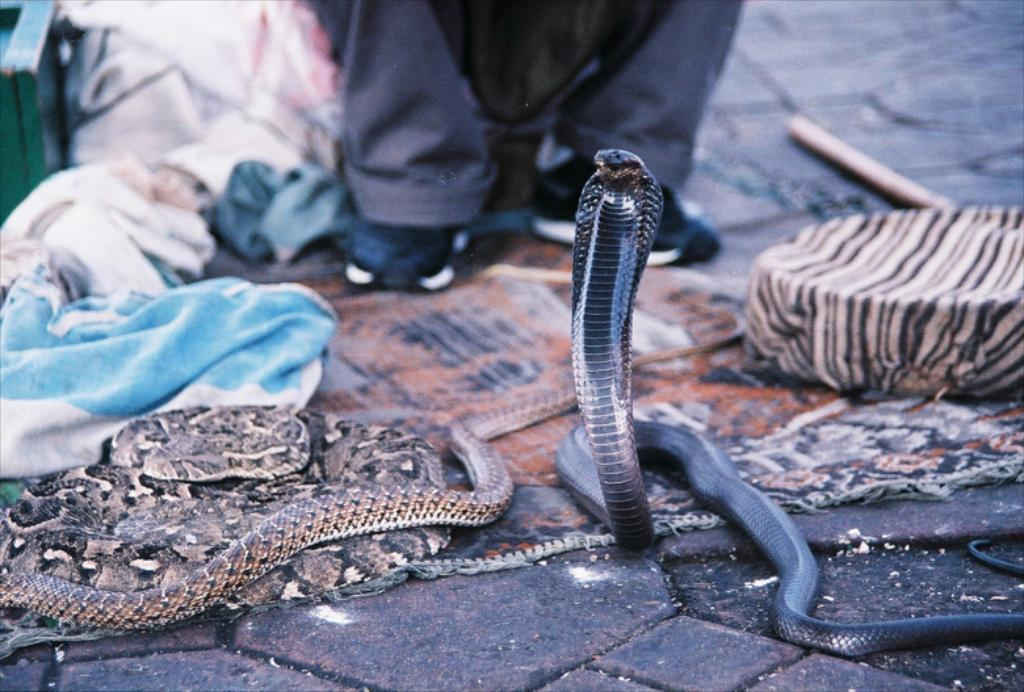What type of animals are present in the image? There are snakes in the image. What is the container for the snakes called? There is a snake box in the image. Where is the snake box located? The snake box is on a mat. What is the surface beneath the mat? The mat is on the land. What other items can be seen in the image? There are clothes and a stick in the image. Are there any people present in the image? Yes, there are people in the image. What type of song is being sung by the snakes in the image? There is no indication in the image that the snakes are singing a song. --- Facts: 1. There is a car in the image. 2. The car is parked on the street. 3. There are trees in the background. 4. The sky is visible in the image. 5. There are people walking on the sidewalk. Absurd Topics: dance, ocean, birdhouse Conversation: What type of vehicle is present in the image? There is a car in the image. Where is the car located? The car is parked on the street. What can be seen in the background of the image? There are trees in the background. What is visible at the top of the image? The sky is visible in the image. What else can be seen in the image? There are people walking on the sidewalk. Reasoning: Let's think step by step in order to produce the conversation. We start by identifying the main subject in the image, which is the car. Then, we expand the conversation to include other items that are also visible, such as the street, trees, sky, and people walking on the sidewalk. Each question is designed to elicit a specific detail about the image that is known from the provided facts. Absurd Question/Answer: Where is the birdhouse located in the image? There is no birdhouse present in the image. 